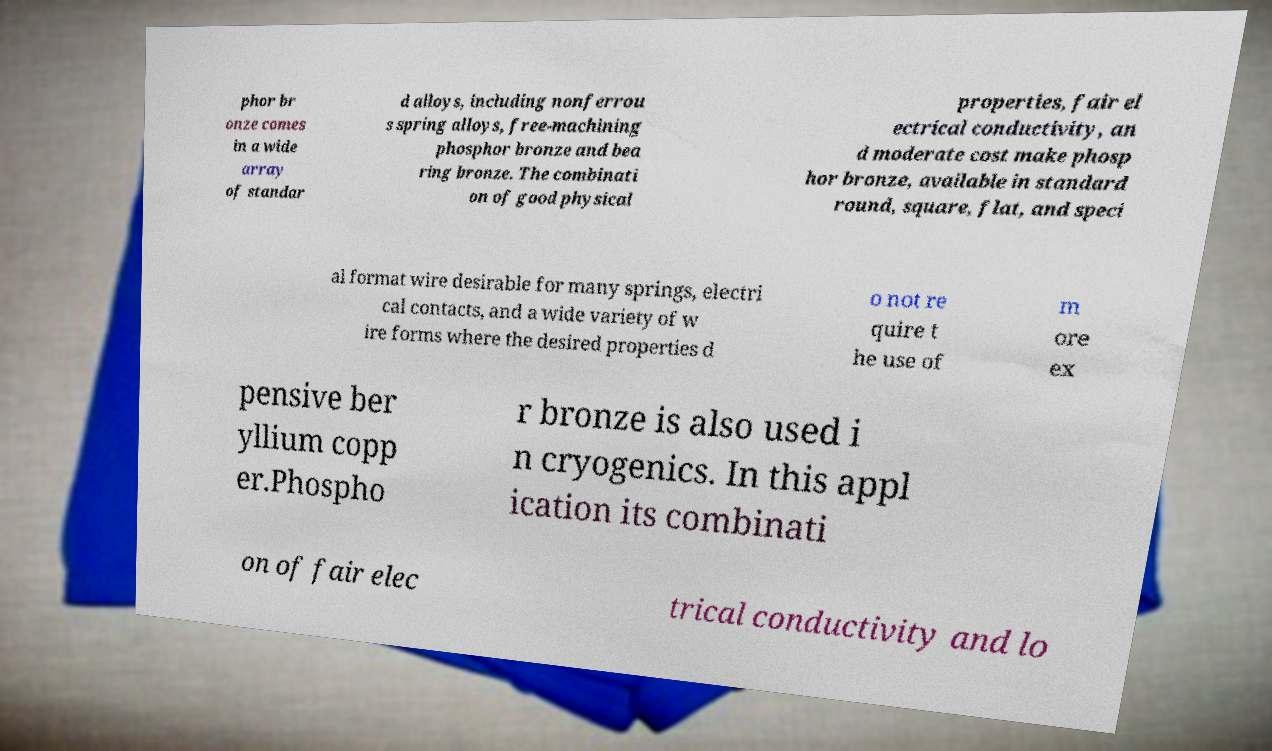Please read and relay the text visible in this image. What does it say? phor br onze comes in a wide array of standar d alloys, including nonferrou s spring alloys, free-machining phosphor bronze and bea ring bronze. The combinati on of good physical properties, fair el ectrical conductivity, an d moderate cost make phosp hor bronze, available in standard round, square, flat, and speci al format wire desirable for many springs, electri cal contacts, and a wide variety of w ire forms where the desired properties d o not re quire t he use of m ore ex pensive ber yllium copp er.Phospho r bronze is also used i n cryogenics. In this appl ication its combinati on of fair elec trical conductivity and lo 